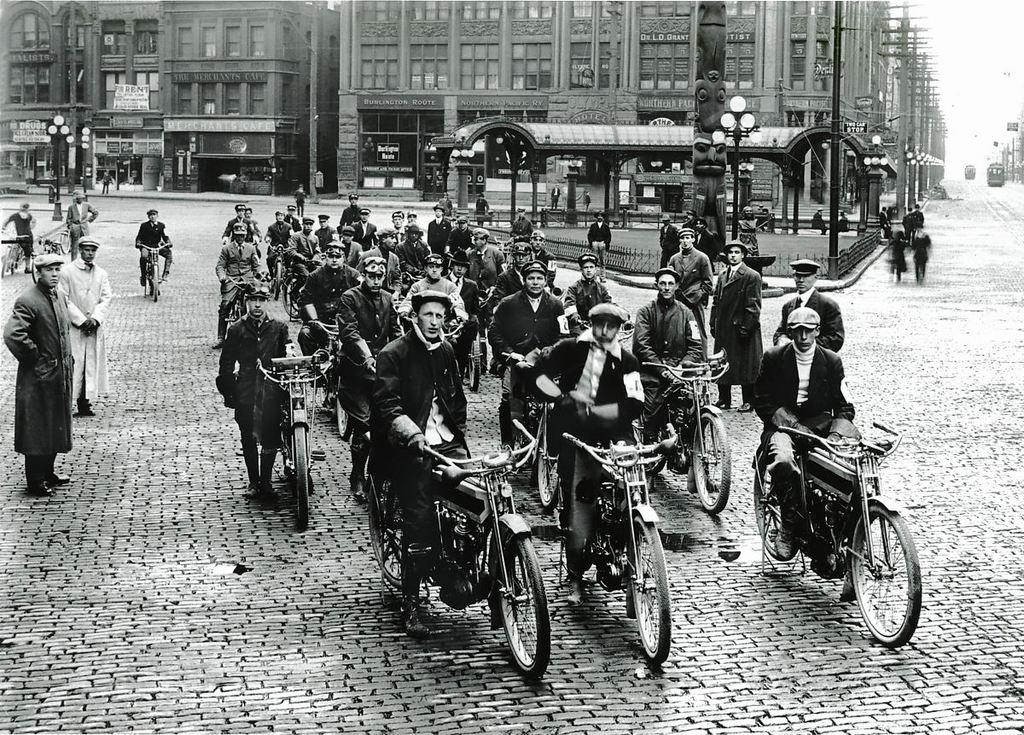What is the color scheme of the image? The image is black and white. What are the people in the image doing? The people in the image are sitting on cycles. What can be seen in the background of the image? There are buildings in the background of the image. What is illuminating the footpath in the image? There are lights on the footpath in the image. Can you tell me how many bats are flying in the image? There are no bats present in the image. What does the stranger sitting on the cycle look like? There is no stranger mentioned in the image; only people are described as sitting on cycles. 